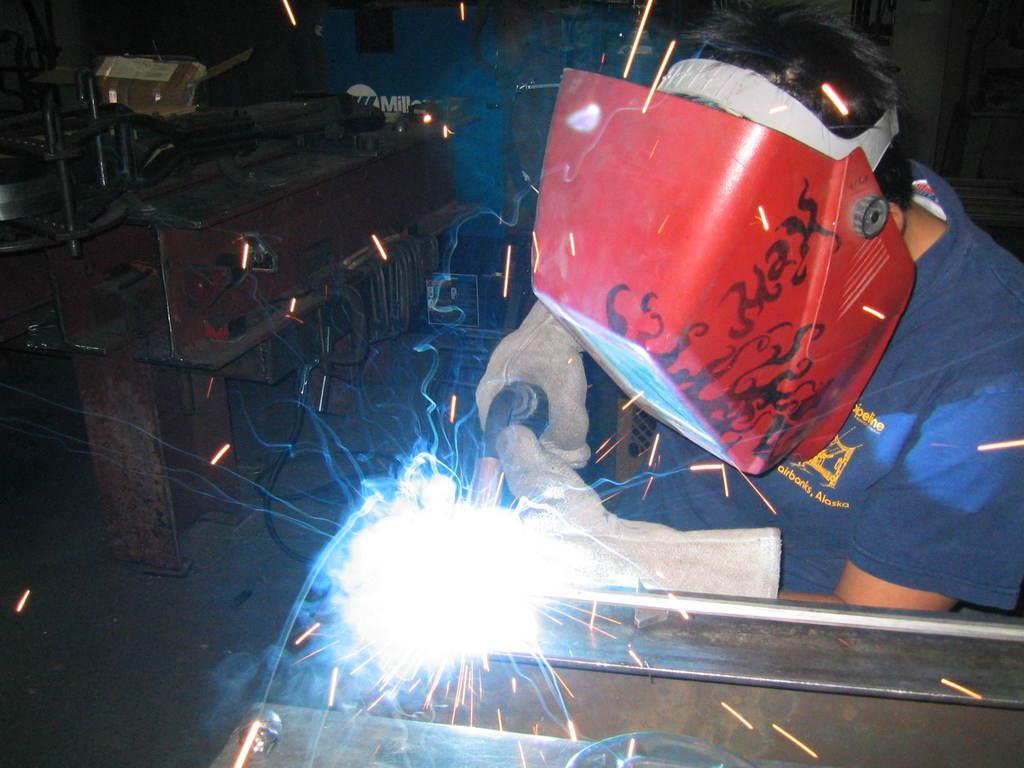Describe this image in one or two sentences. In this picture there is a man who is wearing helmet, gloves and t-shirts. He is doing the welding with the machine. On the left I can see the welding machines and other objects which are placed near to the wall. 